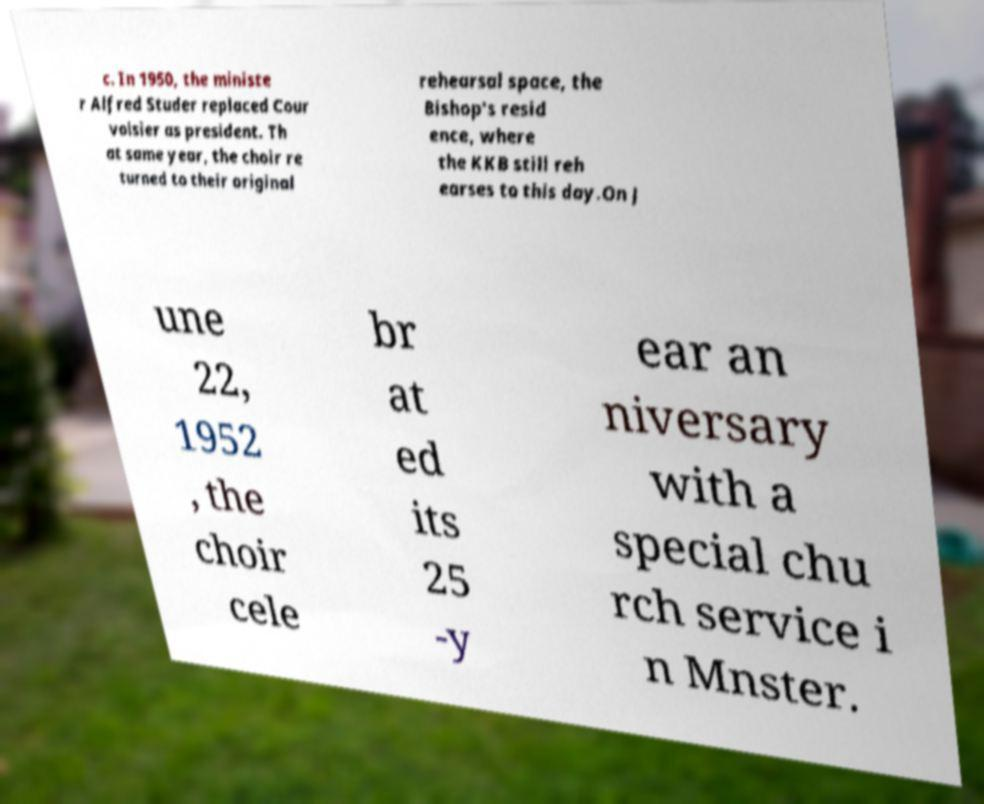Please identify and transcribe the text found in this image. c. In 1950, the ministe r Alfred Studer replaced Cour voisier as president. Th at same year, the choir re turned to their original rehearsal space, the Bishop's resid ence, where the KKB still reh earses to this day.On J une 22, 1952 , the choir cele br at ed its 25 -y ear an niversary with a special chu rch service i n Mnster. 